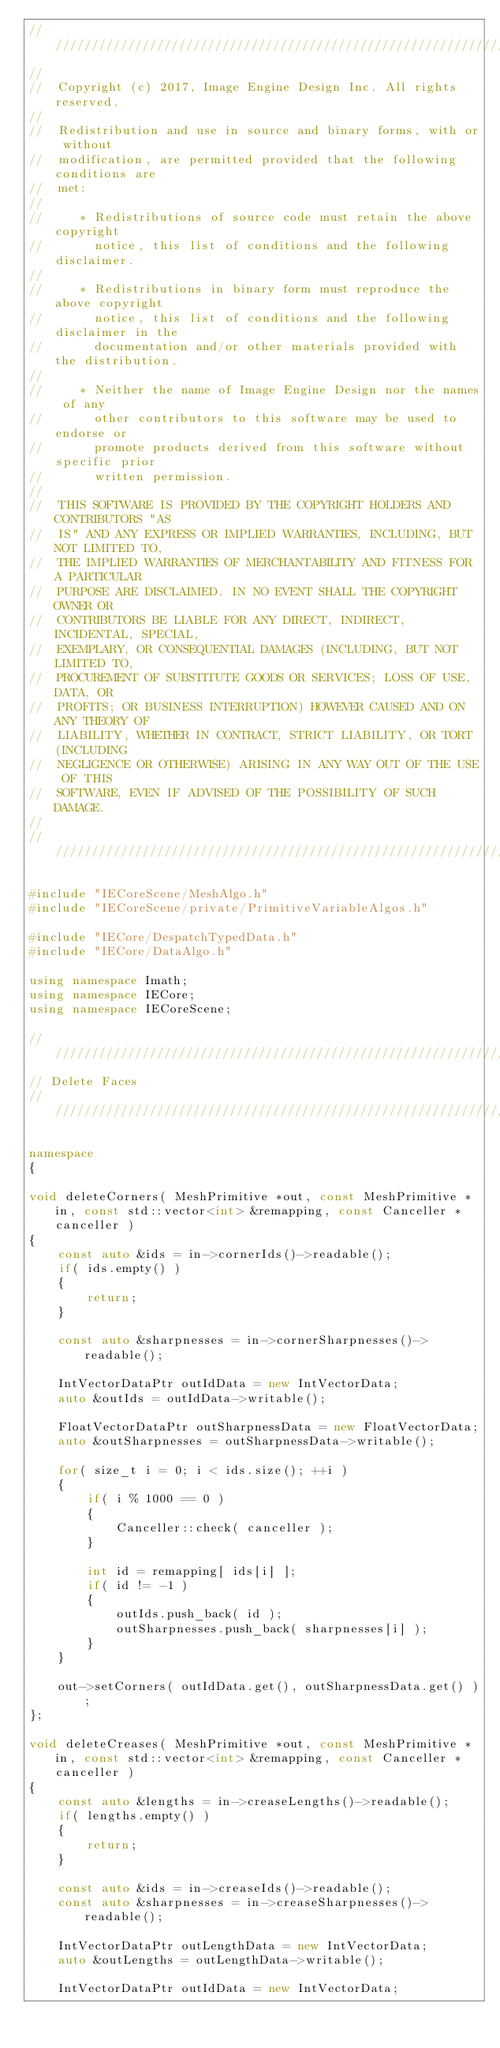<code> <loc_0><loc_0><loc_500><loc_500><_C++_>//////////////////////////////////////////////////////////////////////////
//
//  Copyright (c) 2017, Image Engine Design Inc. All rights reserved.
//
//  Redistribution and use in source and binary forms, with or without
//  modification, are permitted provided that the following conditions are
//  met:
//
//     * Redistributions of source code must retain the above copyright
//       notice, this list of conditions and the following disclaimer.
//
//     * Redistributions in binary form must reproduce the above copyright
//       notice, this list of conditions and the following disclaimer in the
//       documentation and/or other materials provided with the distribution.
//
//     * Neither the name of Image Engine Design nor the names of any
//       other contributors to this software may be used to endorse or
//       promote products derived from this software without specific prior
//       written permission.
//
//  THIS SOFTWARE IS PROVIDED BY THE COPYRIGHT HOLDERS AND CONTRIBUTORS "AS
//  IS" AND ANY EXPRESS OR IMPLIED WARRANTIES, INCLUDING, BUT NOT LIMITED TO,
//  THE IMPLIED WARRANTIES OF MERCHANTABILITY AND FITNESS FOR A PARTICULAR
//  PURPOSE ARE DISCLAIMED. IN NO EVENT SHALL THE COPYRIGHT OWNER OR
//  CONTRIBUTORS BE LIABLE FOR ANY DIRECT, INDIRECT, INCIDENTAL, SPECIAL,
//  EXEMPLARY, OR CONSEQUENTIAL DAMAGES (INCLUDING, BUT NOT LIMITED TO,
//  PROCUREMENT OF SUBSTITUTE GOODS OR SERVICES; LOSS OF USE, DATA, OR
//  PROFITS; OR BUSINESS INTERRUPTION) HOWEVER CAUSED AND ON ANY THEORY OF
//  LIABILITY, WHETHER IN CONTRACT, STRICT LIABILITY, OR TORT (INCLUDING
//  NEGLIGENCE OR OTHERWISE) ARISING IN ANY WAY OUT OF THE USE OF THIS
//  SOFTWARE, EVEN IF ADVISED OF THE POSSIBILITY OF SUCH DAMAGE.
//
//////////////////////////////////////////////////////////////////////////

#include "IECoreScene/MeshAlgo.h"
#include "IECoreScene/private/PrimitiveVariableAlgos.h"

#include "IECore/DespatchTypedData.h"
#include "IECore/DataAlgo.h"

using namespace Imath;
using namespace IECore;
using namespace IECoreScene;

//////////////////////////////////////////////////////////////////////////
// Delete Faces
//////////////////////////////////////////////////////////////////////////

namespace
{

void deleteCorners( MeshPrimitive *out, const MeshPrimitive *in, const std::vector<int> &remapping, const Canceller *canceller )
{
	const auto &ids = in->cornerIds()->readable();
	if( ids.empty() )
	{
		return;
	}

	const auto &sharpnesses = in->cornerSharpnesses()->readable();

	IntVectorDataPtr outIdData = new IntVectorData;
	auto &outIds = outIdData->writable();

	FloatVectorDataPtr outSharpnessData = new FloatVectorData;
	auto &outSharpnesses = outSharpnessData->writable();

	for( size_t i = 0; i < ids.size(); ++i )
	{
		if( i % 1000 == 0 )
		{
			Canceller::check( canceller );
		}

		int id = remapping[ ids[i] ];
		if( id != -1 )
		{
			outIds.push_back( id );
			outSharpnesses.push_back( sharpnesses[i] );
		}
	}

	out->setCorners( outIdData.get(), outSharpnessData.get() );
};

void deleteCreases( MeshPrimitive *out, const MeshPrimitive *in, const std::vector<int> &remapping, const Canceller *canceller )
{
	const auto &lengths = in->creaseLengths()->readable();
	if( lengths.empty() )
	{
		return;
	}

	const auto &ids = in->creaseIds()->readable();
	const auto &sharpnesses = in->creaseSharpnesses()->readable();

	IntVectorDataPtr outLengthData = new IntVectorData;
	auto &outLengths = outLengthData->writable();

	IntVectorDataPtr outIdData = new IntVectorData;</code> 